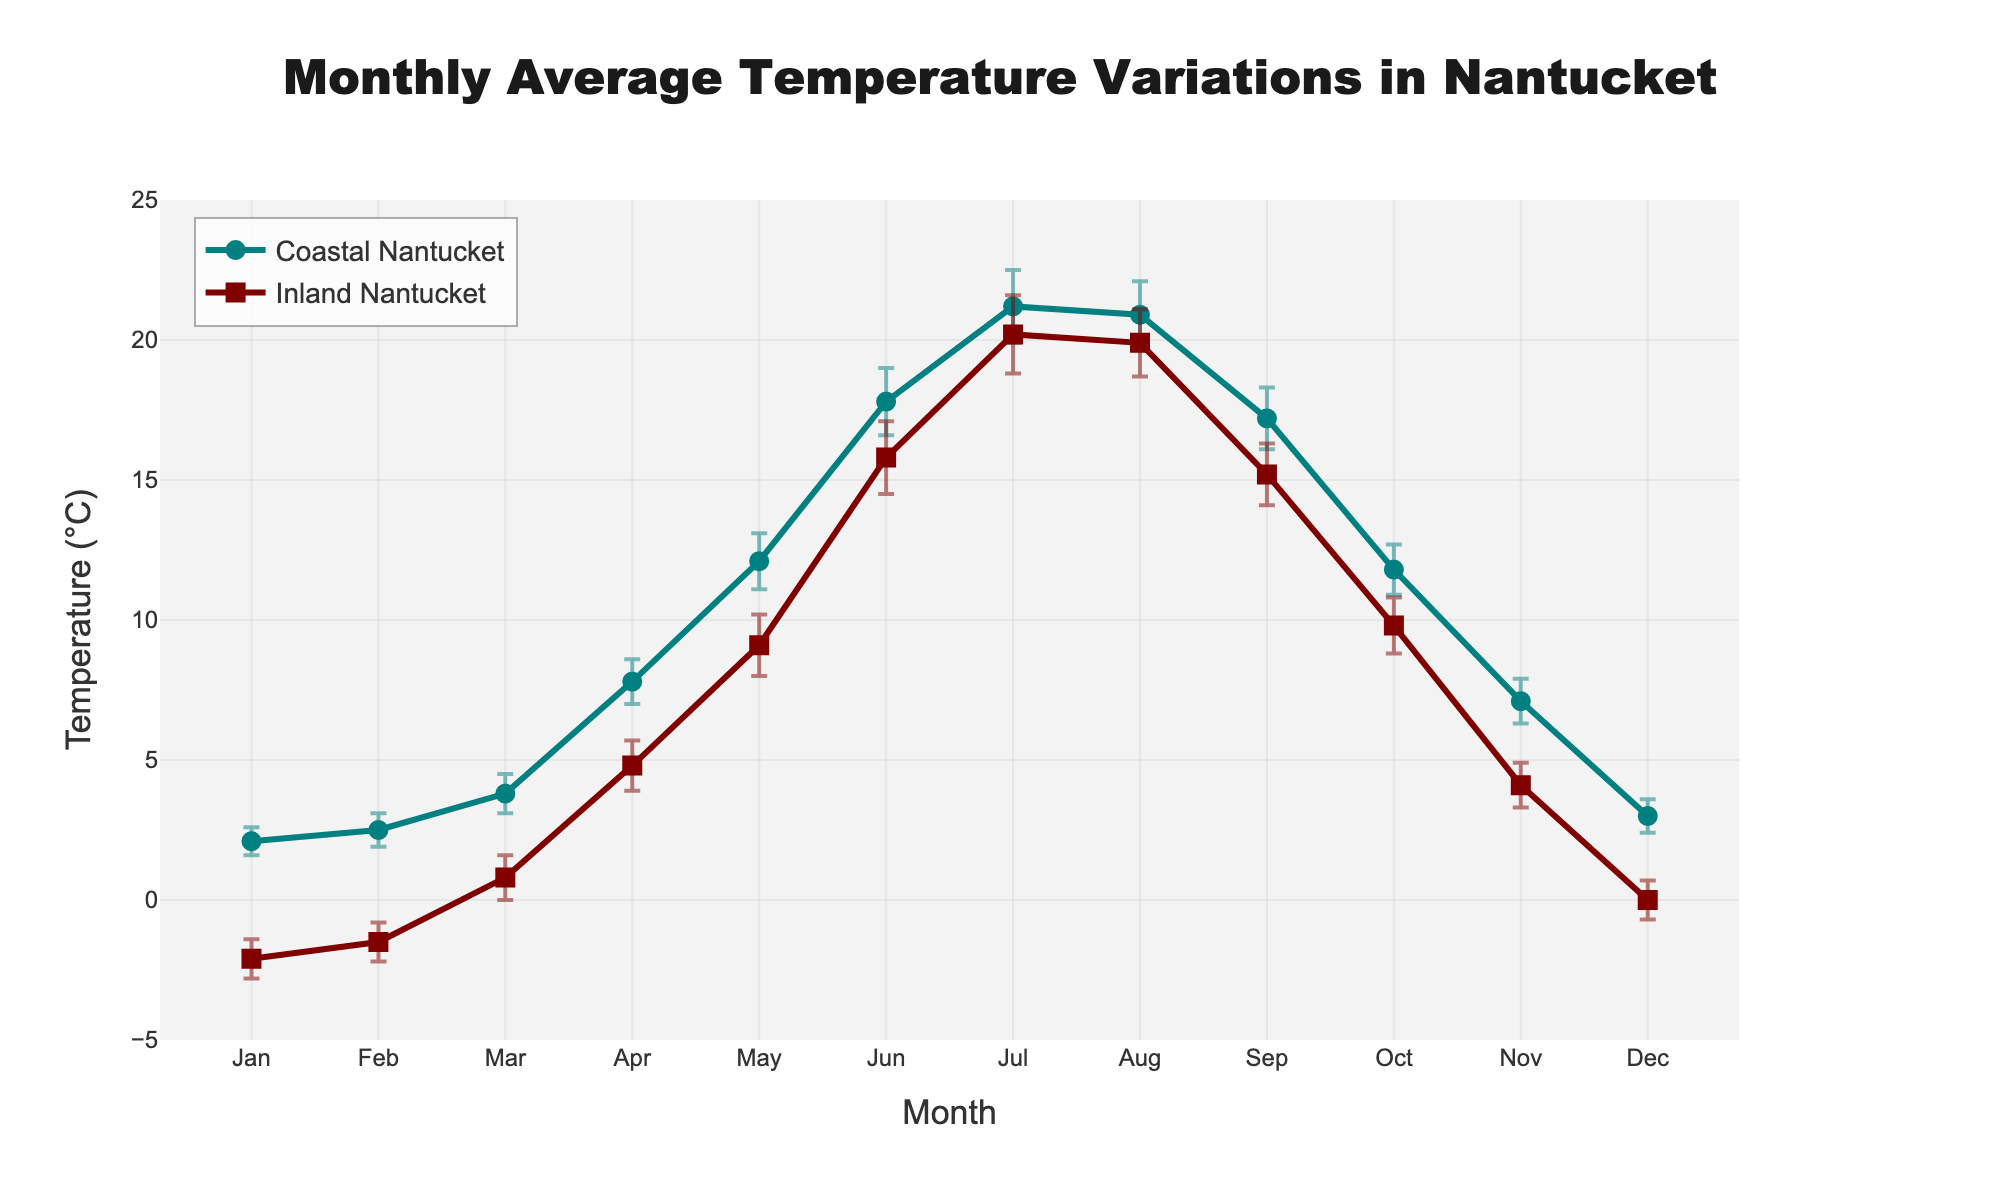What is the y-axis title? The y-axis title is located along the vertical axis of the graph. It indicates the variable being measured on this axis, which helps to understand the plotted data points.
Answer: Temperature (°C) How many months are displayed on the x-axis? The number of months shown on the x-axis corresponds to the data points laid out across the months of the year. By counting the month labels, we can determine the total number displayed.
Answer: 12 Which month shows the highest average temperature for Coastal Nantucket? To find the highest average temperature for Coastal Nantucket, we look for the peak data point on the coastal line (teal color). The month corresponding to this peak is our answer.
Answer: July What is the difference in average temperature between Inland Nantucket and Coastal Nantucket for January? First, identify the average temperature for both locations in January from the plot. Then, calculate the difference by subtracting the inland temperature from the coastal temperature.
Answer: 4.2°C (2.1 - (-2.1)) How does the error bar size for Coastal Nantucket in May compare with that in July? Compare the lengths of the error bars for Coastal Nantucket in May and July visually. Look at the extent of the error bars above and below the data points for these months.
Answer: May has smaller error bars than July Which region, Coastal or Inland Nantucket, has a smaller average temperature variation over the year? Assess the range of temperature values from the highest to the lowest for each region (difference between the highest and lowest data points). The region with the smaller range has less variation.
Answer: Coastal Nantucket During which months does Coastal Nantucket have higher temperatures than Inland Nantucket? For each month, compare the coastal and inland temperatures. Identify the months where the temperature of Coastal Nantucket is greater than that of Inland Nantucket.
Answer: January, February, March, April, May, June, August, September, October, November, December What is the average temperature in July for both regions, and how do they compare? Locate the average temperature for both regions in July. Next, compare these temperatures side by side to understand the difference.
Answer: Coastal Nantucket: 21.2°C, Inland Nantucket: 20.2°C; Coastal is higher by 1.0°C Are error bars generally larger for Coastal or Inland Nantucket? Visually inspect the error bars across all months for both regions. Summarize which region tends to have larger error bars on average.
Answer: Inland Nantucket has larger error bars What months display the smallest temperature difference between Coastal and Inland Nantucket? Calculate the temperature difference for each month by subtracting the inland temperature from the coastal temperature. Identify the months with the smallest absolute differences.
Answer: August, September (both with 1.0°C) 